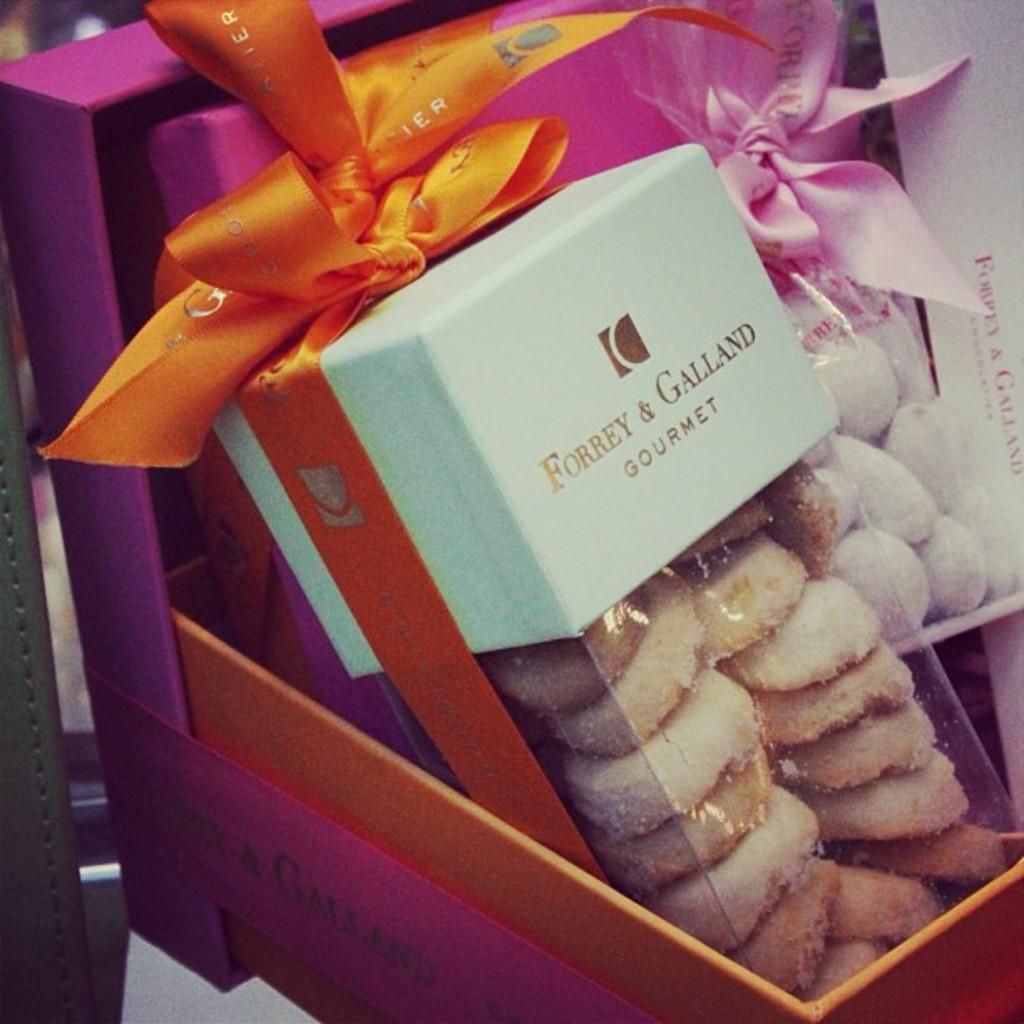Could you give a brief overview of what you see in this image? In this image I can see few cookies in the box and the box is in purple color. I can also see two ribbons in orange and pink color. 